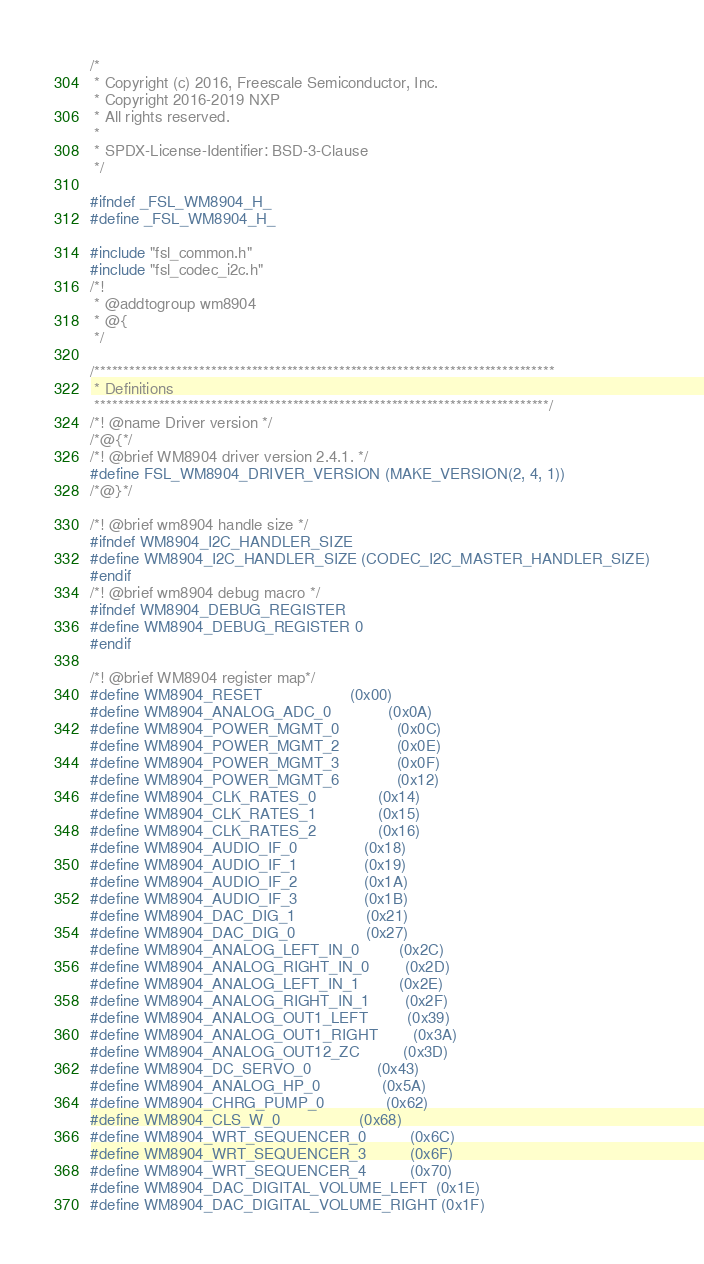Convert code to text. <code><loc_0><loc_0><loc_500><loc_500><_C_>/*
 * Copyright (c) 2016, Freescale Semiconductor, Inc.
 * Copyright 2016-2019 NXP
 * All rights reserved.
 *
 * SPDX-License-Identifier: BSD-3-Clause
 */

#ifndef _FSL_WM8904_H_
#define _FSL_WM8904_H_

#include "fsl_common.h"
#include "fsl_codec_i2c.h"
/*!
 * @addtogroup wm8904
 * @{
 */

/*******************************************************************************
 * Definitions
 ******************************************************************************/
/*! @name Driver version */
/*@{*/
/*! @brief WM8904 driver version 2.4.1. */
#define FSL_WM8904_DRIVER_VERSION (MAKE_VERSION(2, 4, 1))
/*@}*/

/*! @brief wm8904 handle size */
#ifndef WM8904_I2C_HANDLER_SIZE
#define WM8904_I2C_HANDLER_SIZE (CODEC_I2C_MASTER_HANDLER_SIZE)
#endif
/*! @brief wm8904 debug macro */
#ifndef WM8904_DEBUG_REGISTER
#define WM8904_DEBUG_REGISTER 0
#endif

/*! @brief WM8904 register map*/
#define WM8904_RESET                    (0x00)
#define WM8904_ANALOG_ADC_0             (0x0A)
#define WM8904_POWER_MGMT_0             (0x0C)
#define WM8904_POWER_MGMT_2             (0x0E)
#define WM8904_POWER_MGMT_3             (0x0F)
#define WM8904_POWER_MGMT_6             (0x12)
#define WM8904_CLK_RATES_0              (0x14)
#define WM8904_CLK_RATES_1              (0x15)
#define WM8904_CLK_RATES_2              (0x16)
#define WM8904_AUDIO_IF_0               (0x18)
#define WM8904_AUDIO_IF_1               (0x19)
#define WM8904_AUDIO_IF_2               (0x1A)
#define WM8904_AUDIO_IF_3               (0x1B)
#define WM8904_DAC_DIG_1                (0x21)
#define WM8904_DAC_DIG_0                (0x27)
#define WM8904_ANALOG_LEFT_IN_0         (0x2C)
#define WM8904_ANALOG_RIGHT_IN_0        (0x2D)
#define WM8904_ANALOG_LEFT_IN_1         (0x2E)
#define WM8904_ANALOG_RIGHT_IN_1        (0x2F)
#define WM8904_ANALOG_OUT1_LEFT         (0x39)
#define WM8904_ANALOG_OUT1_RIGHT        (0x3A)
#define WM8904_ANALOG_OUT12_ZC          (0x3D)
#define WM8904_DC_SERVO_0               (0x43)
#define WM8904_ANALOG_HP_0              (0x5A)
#define WM8904_CHRG_PUMP_0              (0x62)
#define WM8904_CLS_W_0                  (0x68)
#define WM8904_WRT_SEQUENCER_0          (0x6C)
#define WM8904_WRT_SEQUENCER_3          (0x6F)
#define WM8904_WRT_SEQUENCER_4          (0x70)
#define WM8904_DAC_DIGITAL_VOLUME_LEFT  (0x1E)
#define WM8904_DAC_DIGITAL_VOLUME_RIGHT (0x1F)</code> 